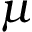Convert formula to latex. <formula><loc_0><loc_0><loc_500><loc_500>\mu</formula> 